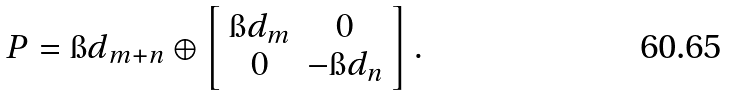<formula> <loc_0><loc_0><loc_500><loc_500>P = { \i d } _ { m + n } \oplus \left [ \begin{array} { c c } \i d _ { m } & 0 \\ 0 & - \i d _ { n } \end{array} \right ] .</formula> 